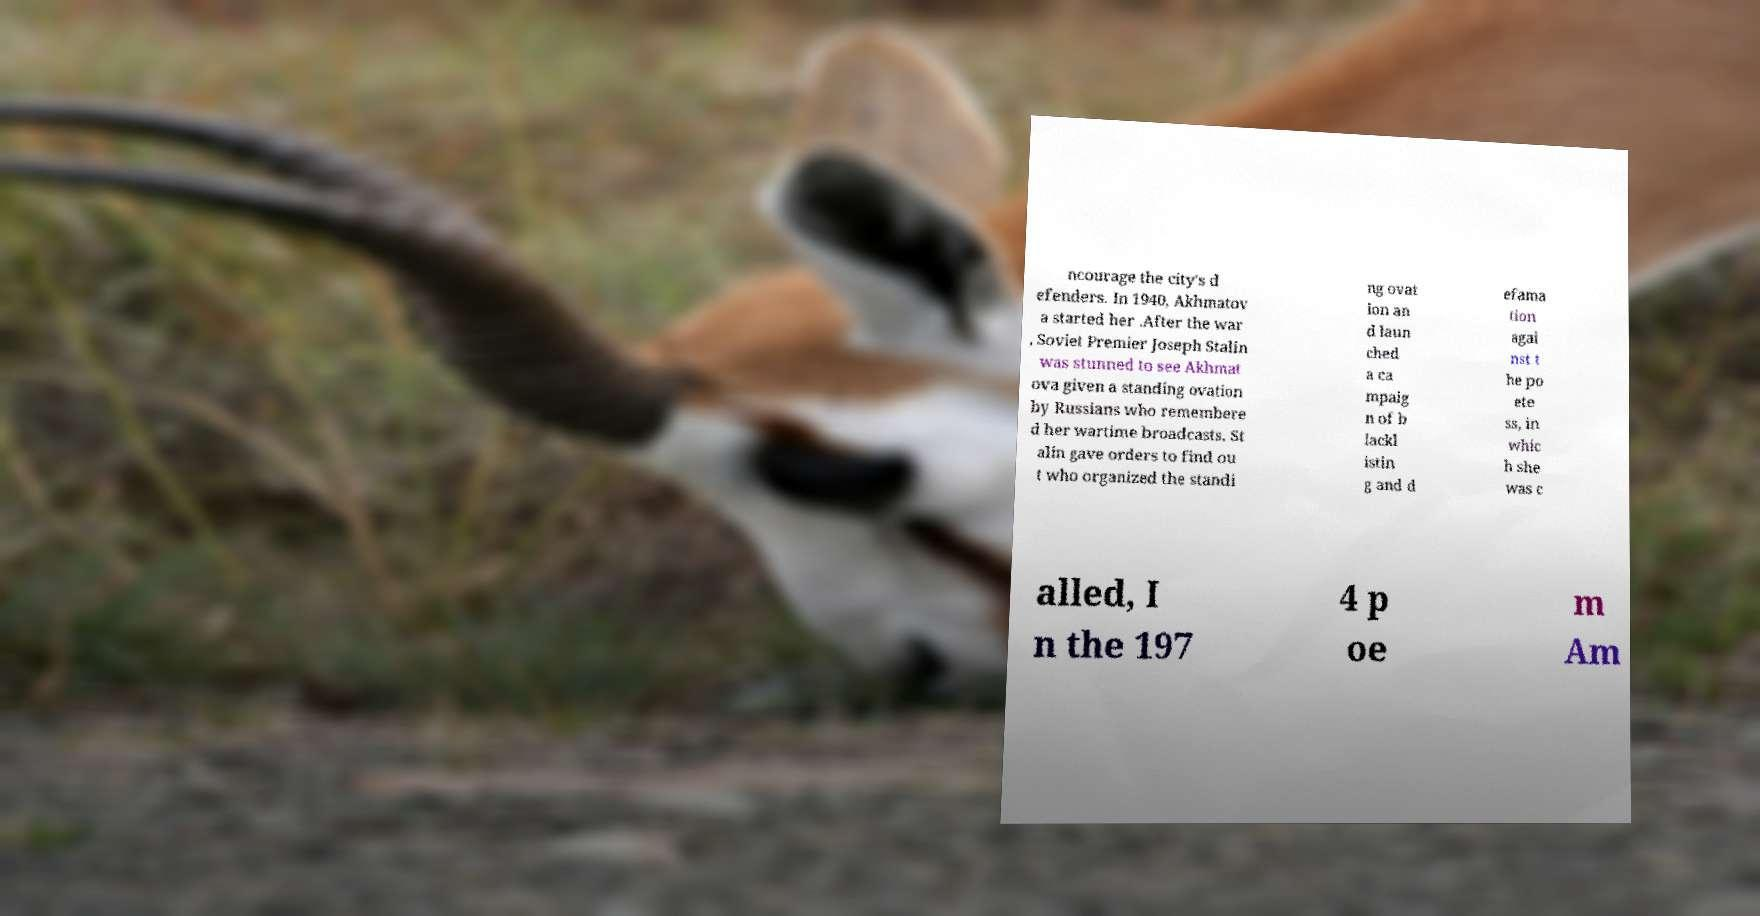Please identify and transcribe the text found in this image. ncourage the city's d efenders. In 1940, Akhmatov a started her .After the war , Soviet Premier Joseph Stalin was stunned to see Akhmat ova given a standing ovation by Russians who remembere d her wartime broadcasts. St alin gave orders to find ou t who organized the standi ng ovat ion an d laun ched a ca mpaig n of b lackl istin g and d efama tion agai nst t he po ete ss, in whic h she was c alled, I n the 197 4 p oe m Am 